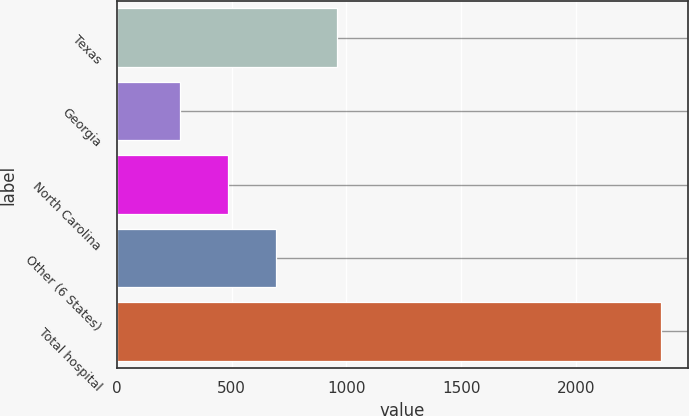Convert chart to OTSL. <chart><loc_0><loc_0><loc_500><loc_500><bar_chart><fcel>Texas<fcel>Georgia<fcel>North Carolina<fcel>Other (6 States)<fcel>Total hospital<nl><fcel>959<fcel>274<fcel>483.4<fcel>692.8<fcel>2368<nl></chart> 